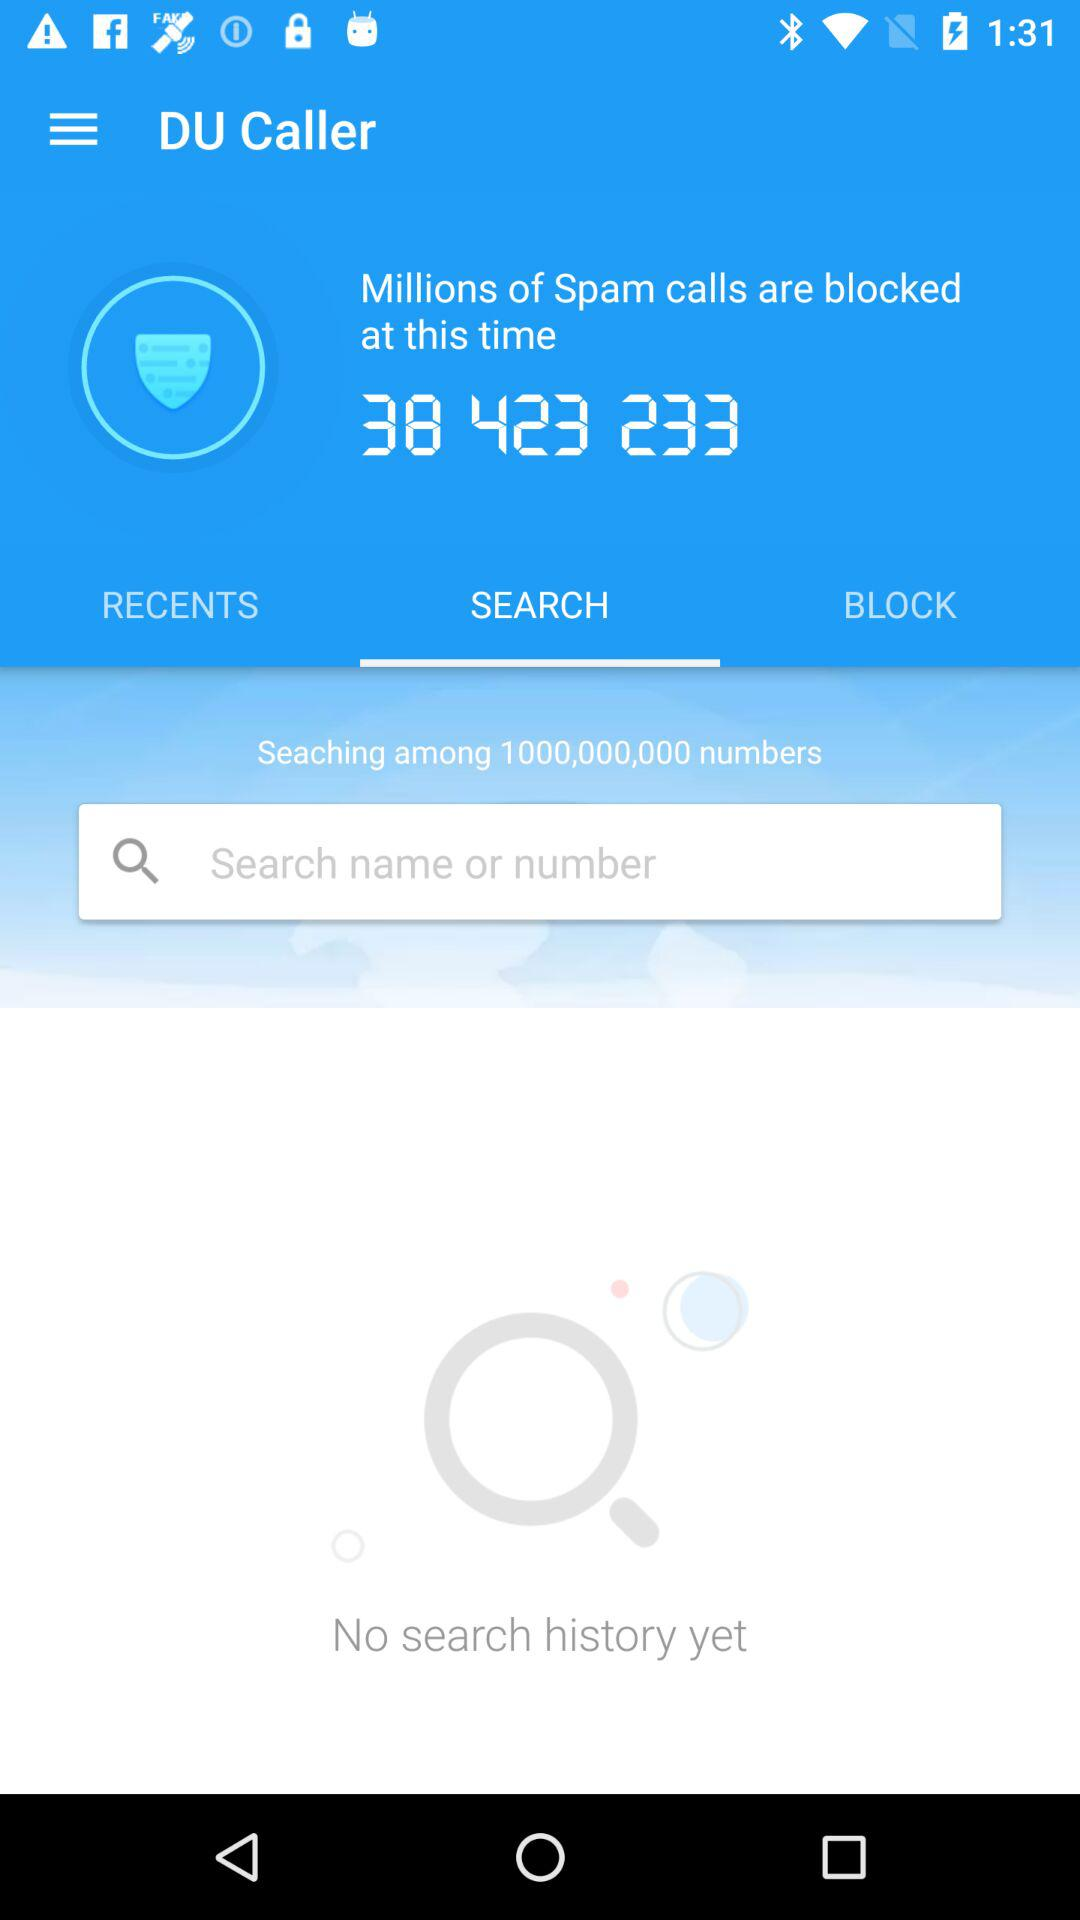How many spam calls are blocked? The number of scam calls blocked is 38,423,233. 